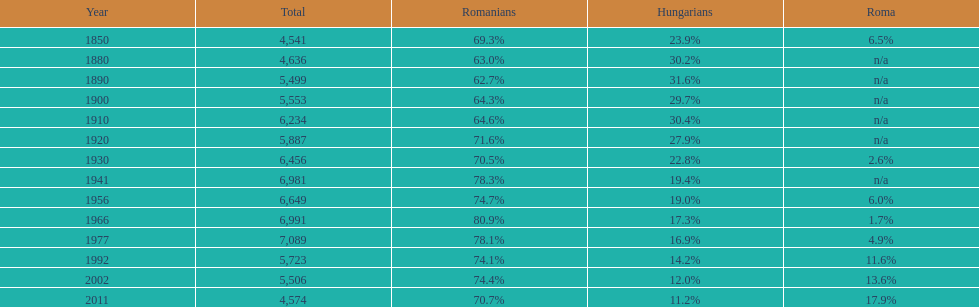Which year had a total of 6,981 and 19.4% hungarians? 1941. 